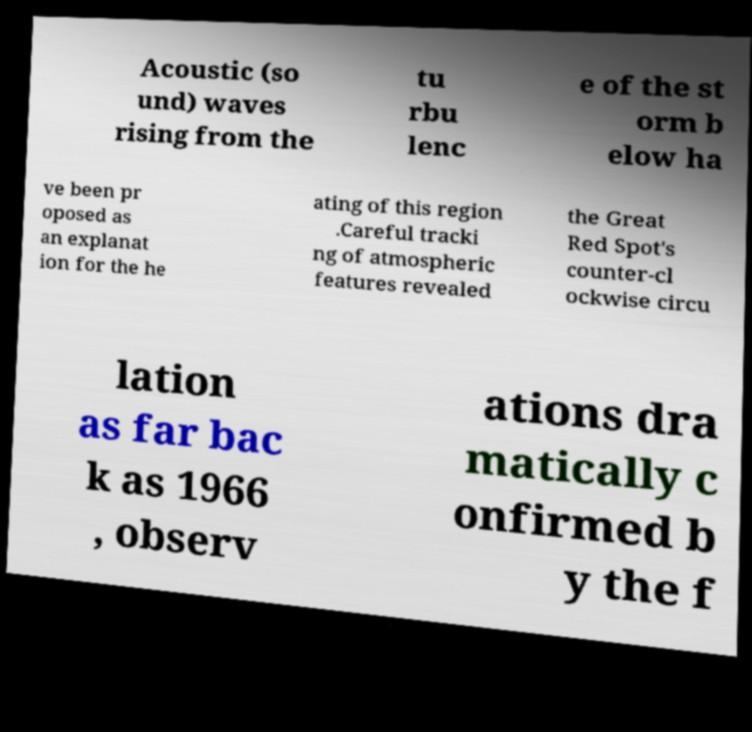Could you assist in decoding the text presented in this image and type it out clearly? Acoustic (so und) waves rising from the tu rbu lenc e of the st orm b elow ha ve been pr oposed as an explanat ion for the he ating of this region .Careful tracki ng of atmospheric features revealed the Great Red Spot's counter-cl ockwise circu lation as far bac k as 1966 , observ ations dra matically c onfirmed b y the f 